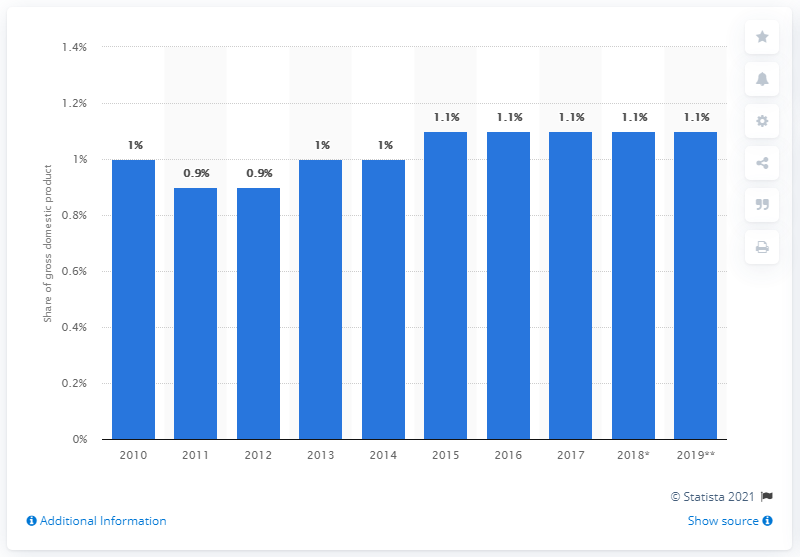Mention a couple of crucial points in this snapshot. Since 2015, the share of private final consumption expenditure on alcoholic beverages and tobacco has remained constant. In 2019, private final consumption expenditure on alcoholic beverages and tobacco accounted for 1.1% of the GDP. 